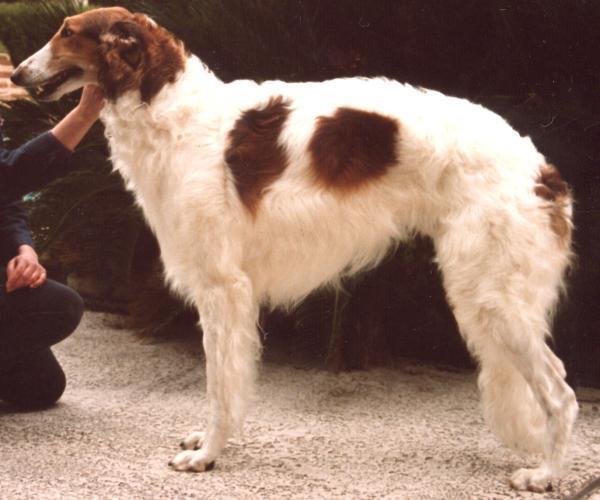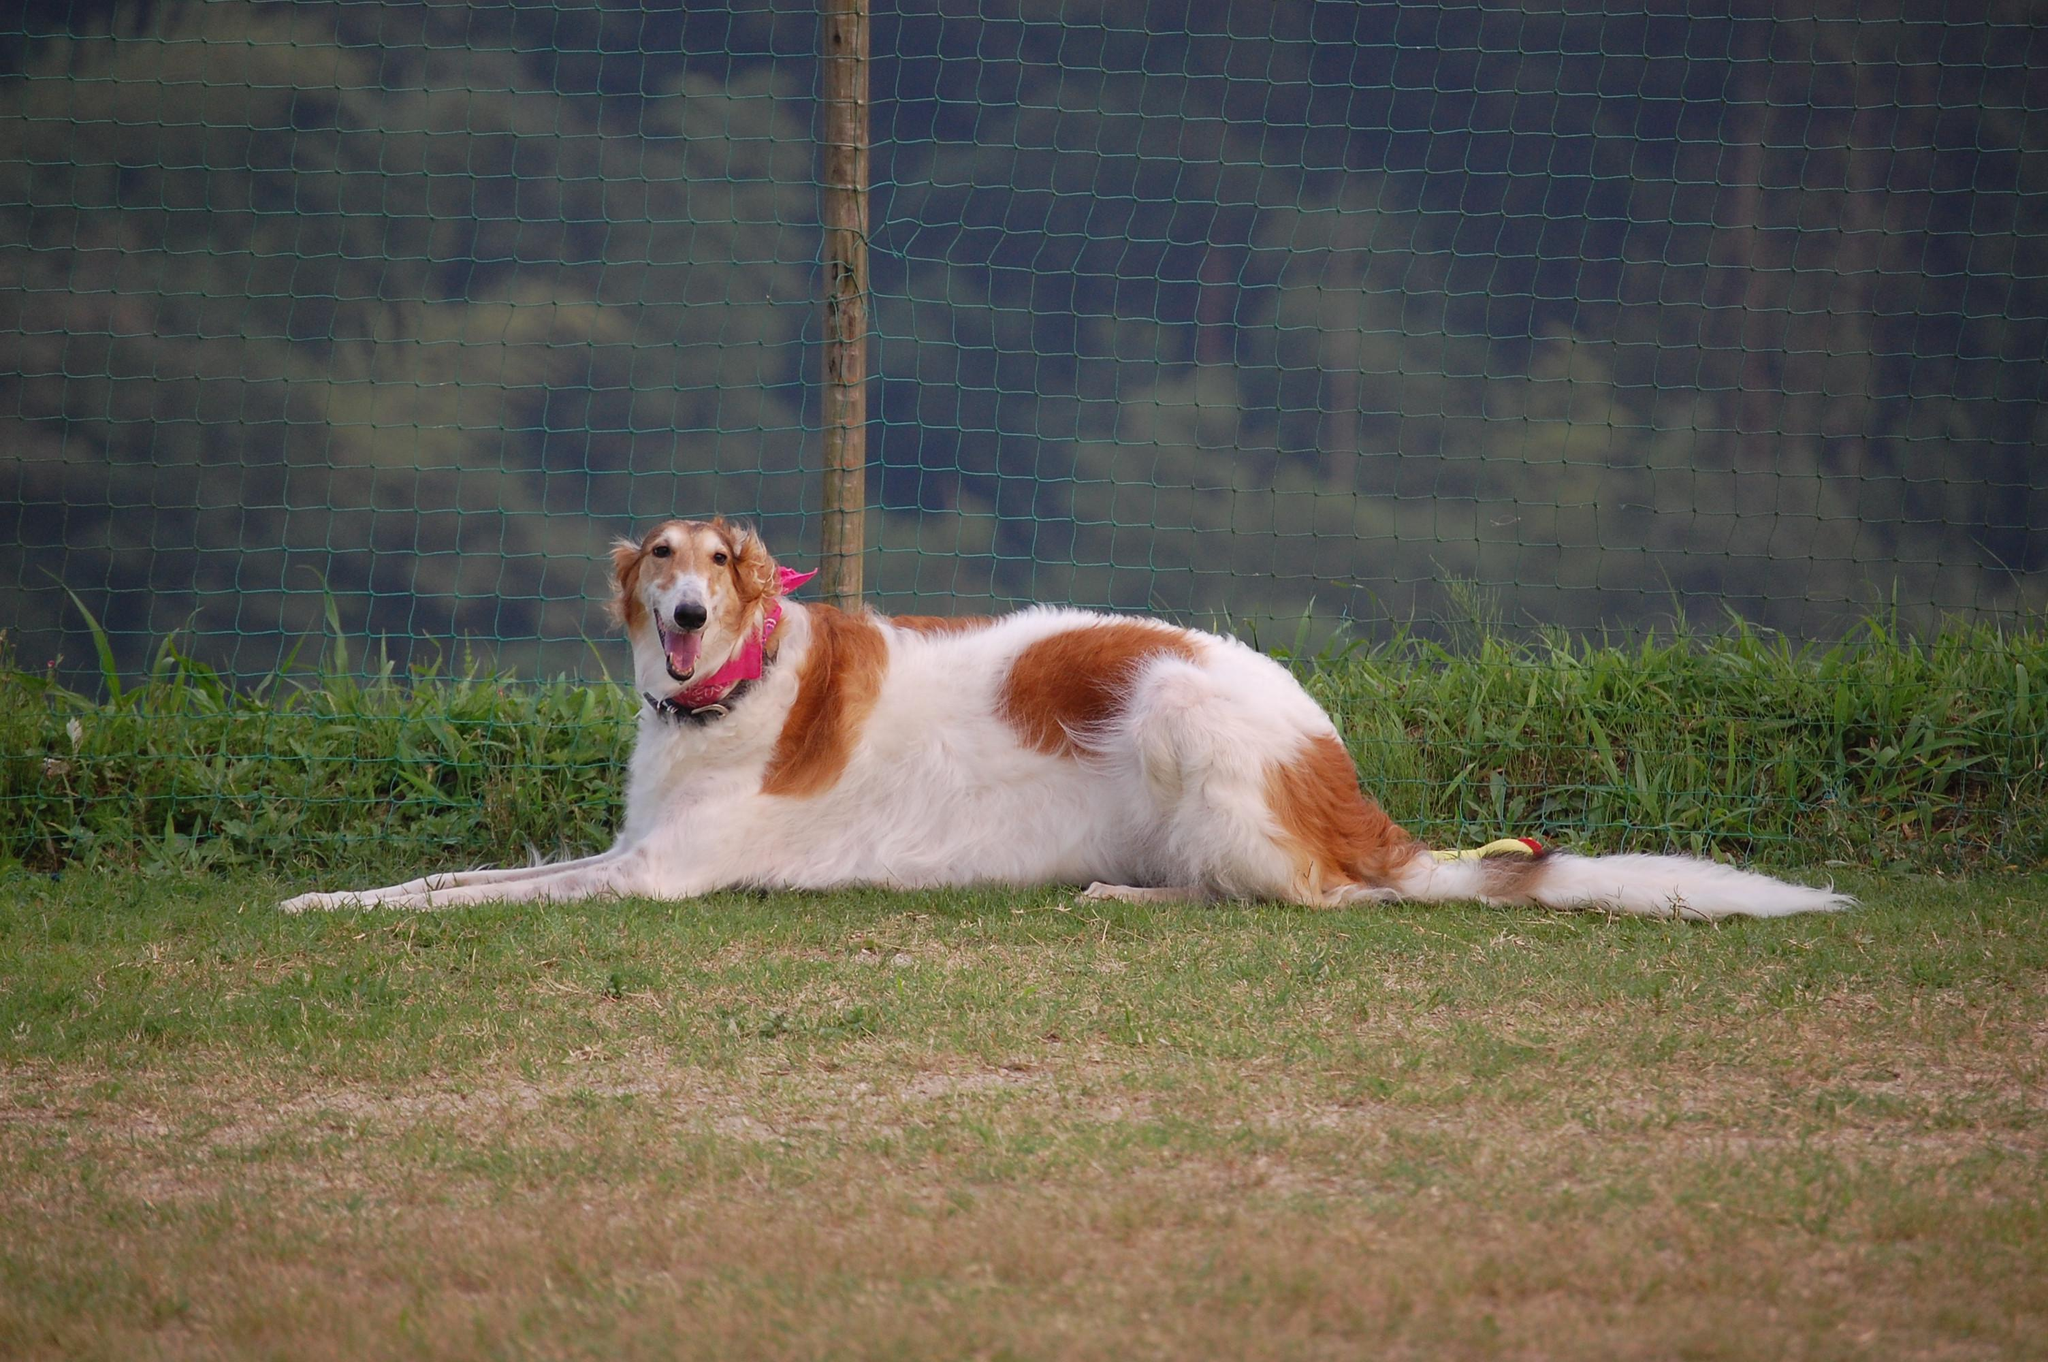The first image is the image on the left, the second image is the image on the right. Considering the images on both sides, is "All dogs are orange-and-white hounds standing with their bodies turned to the left, but one dog is looking back over its shoulder." valid? Answer yes or no. No. The first image is the image on the left, the second image is the image on the right. Considering the images on both sides, is "One dog's mouth is open and the other dog's mouth is closed." valid? Answer yes or no. No. 